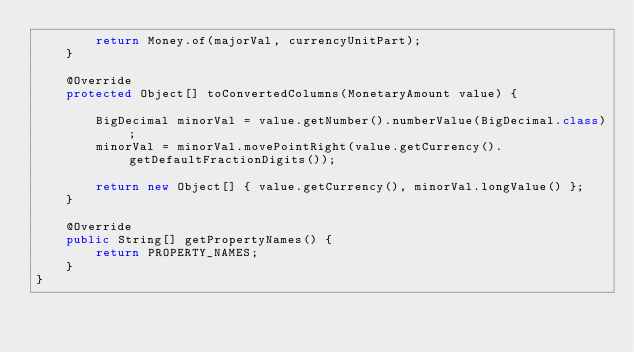Convert code to text. <code><loc_0><loc_0><loc_500><loc_500><_Java_>        return Money.of(majorVal, currencyUnitPart);
    }

    @Override
    protected Object[] toConvertedColumns(MonetaryAmount value) {

        BigDecimal minorVal = value.getNumber().numberValue(BigDecimal.class);
        minorVal = minorVal.movePointRight(value.getCurrency().getDefaultFractionDigits());

        return new Object[] { value.getCurrency(), minorVal.longValue() };
    }

    @Override
    public String[] getPropertyNames() {
        return PROPERTY_NAMES;
    }
}
</code> 